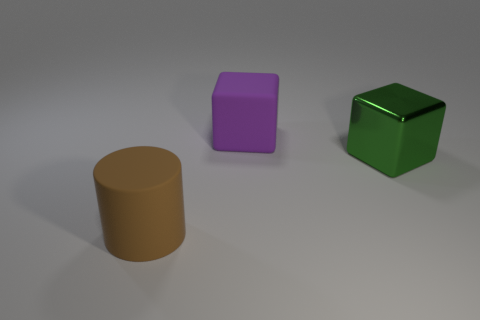Add 3 large brown objects. How many objects exist? 6 Subtract 0 yellow cylinders. How many objects are left? 3 Subtract all blocks. How many objects are left? 1 Subtract 1 blocks. How many blocks are left? 1 Subtract all purple cylinders. Subtract all red blocks. How many cylinders are left? 1 Subtract all brown cylinders. How many green cubes are left? 1 Subtract all yellow cylinders. Subtract all big cylinders. How many objects are left? 2 Add 3 large cylinders. How many large cylinders are left? 4 Add 2 brown objects. How many brown objects exist? 3 